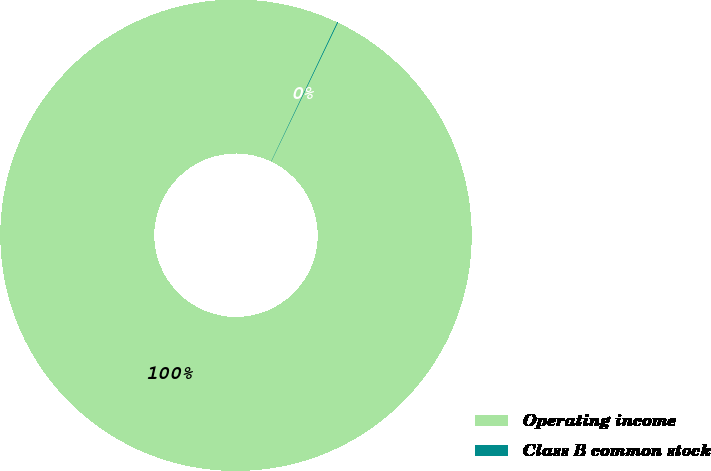Convert chart to OTSL. <chart><loc_0><loc_0><loc_500><loc_500><pie_chart><fcel>Operating income<fcel>Class B common stock<nl><fcel>99.95%<fcel>0.05%<nl></chart> 